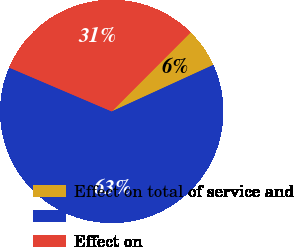<chart> <loc_0><loc_0><loc_500><loc_500><pie_chart><fcel>Effect on total of service and<fcel>Unnamed: 1<fcel>Effect on<nl><fcel>5.68%<fcel>63.26%<fcel>31.06%<nl></chart> 